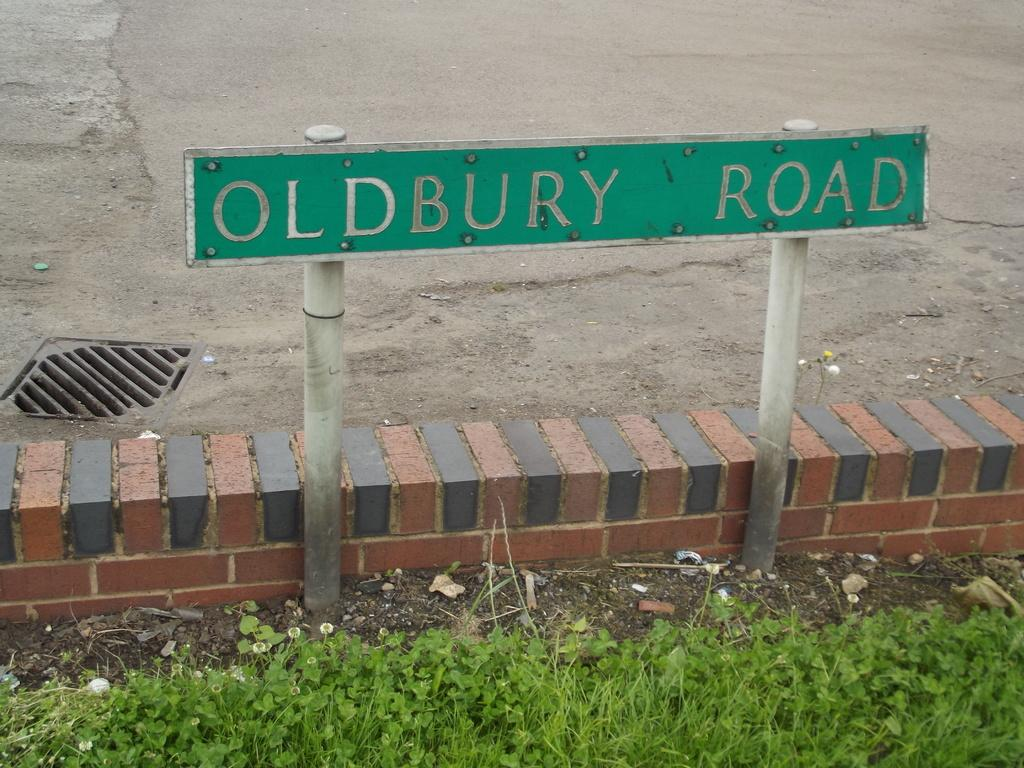What type of living organisms can be seen in the image? Plants can be seen in the image. What object is located in the middle of the image? There is a board in the middle of the image. What type of structure is on the left side of the image? There is a manhole on the left side of the image. What color is the kite that the daughter is holding in the image? There is no daughter or kite present in the image. How many nails are visible in the image? There are no nails visible in the image. 